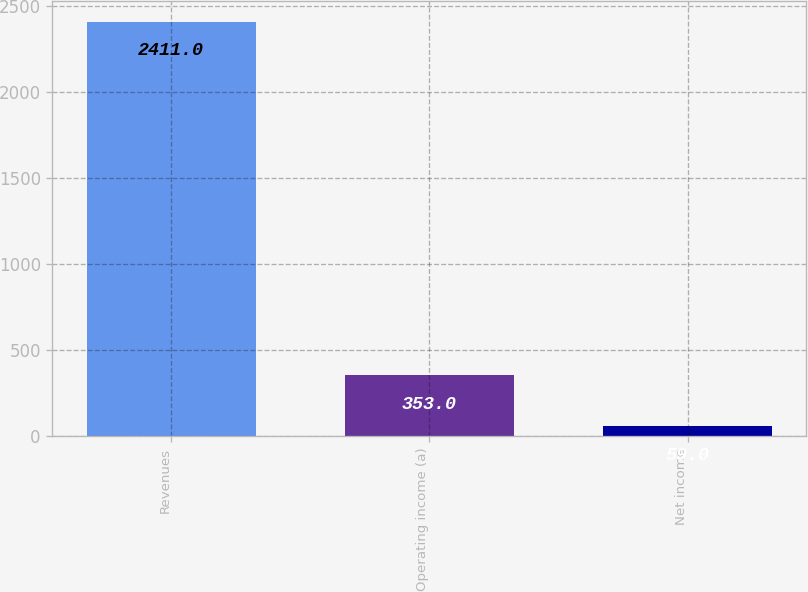Convert chart. <chart><loc_0><loc_0><loc_500><loc_500><bar_chart><fcel>Revenues<fcel>Operating income (a)<fcel>Net income<nl><fcel>2411<fcel>353<fcel>59<nl></chart> 